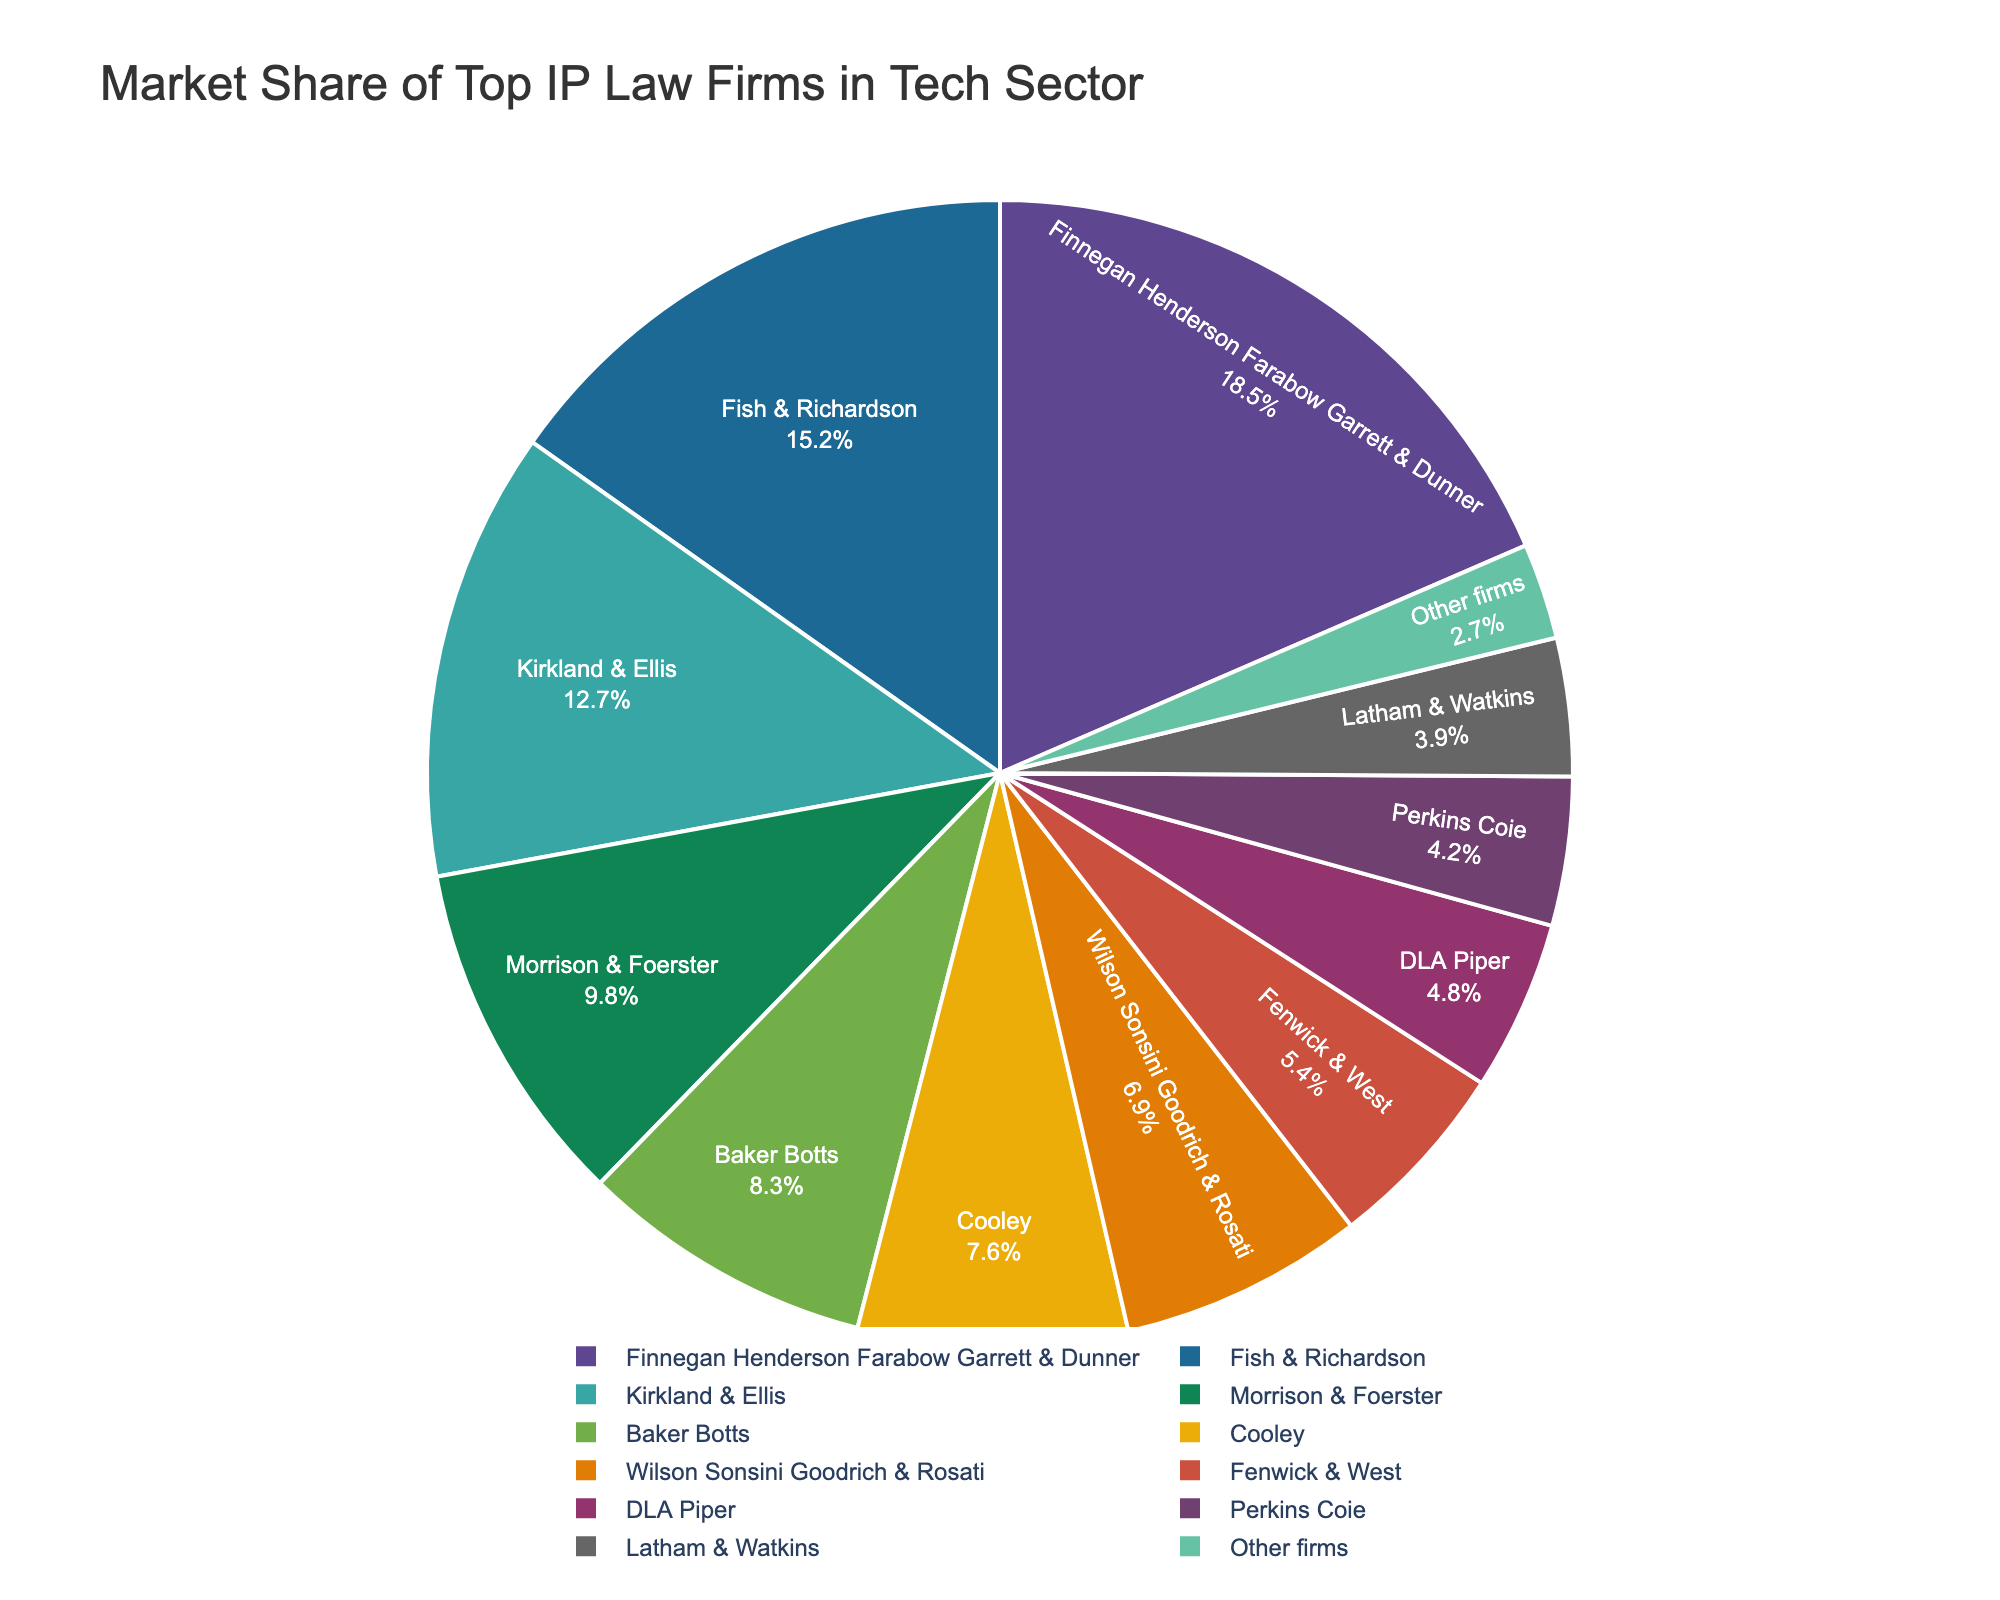What is the market share of the firm with the highest market share? Look for the firm with the largest wedge in the pie chart. The wedge representing Finnegan Henderson Farabow Garrett & Dunner is the largest with 18.5%.
Answer: 18.5% Which firm has the lowest market share, and what is it? Identify the smallest wedge and its corresponding firm. The smallest wedge represents "Other firms" with a market share of 2.7%.
Answer: Other firms, 2.7% How much more market share does Finnegan Henderson Farabow Garrett & Dunner have compared to Fish & Richardson? Subtract the market share of Fish & Richardson (15.2%) from that of Finnegan Henderson Farabow Garrett & Dunner (18.5%). 18.5% - 15.2% = 3.3%.
Answer: 3.3% What is the combined market share of the firms Baker Botts and Cooley? Add the market shares of Baker Botts (8.3%) and Cooley (7.6%). 8.3% + 7.6% = 15.9%.
Answer: 15.9% Which firm appears third in terms of market share? Identify the third-largest wedge in the pie chart. Kirkland & Ellis is third with 12.7%.
Answer: Kirkland & Ellis How does the market share of Morrison & Foerster compare to that of Wilson Sonsini Goodrich & Rosati? Compare the market shares of Morrison & Foerster (9.8%) and Wilson Sonsini Goodrich & Rosati (6.9%). Morrison & Foerster has a higher market share.
Answer: Morrison & Foerster has a higher market share What is the market share range of the top five firms? Identify the market share of the firm with the highest share (Finnegan Henderson Farabow Garrett & Dunner with 18.5%) and the fifth highest share (Baker Botts with 8.3%). The range is 18.5% - 8.3% = 10.2%.
Answer: 10.2% What percentage of the market is held by firms other than the top ten listed firms? Identify the market share labeled "Other firms" which is outside the top ten firms. The market share for "Other firms" is 2.7%.
Answer: 2.7% If you combine the market shares of Fenwick & West and DLA Piper, do they collectively have more market share than Kirkland & Ellis? Add the market shares of Fenwick & West (5.4%) and DLA Piper (4.8%) and compare it to that of Kirkland & Ellis (12.7%). 5.4% + 4.8% = 10.2%, which is less than 12.7%.
Answer: No, they do not Which firms combined make up over 50% of the market? Sequentially add the market shares starting from the highest until the sum exceeds 50%. Finnegan Henderson Farabow Garrett & Dunner (18.5%) + Fish & Richardson (15.2%) + Kirkland & Ellis (12.7%) + Morrison & Foerster (9.8%) = 56.2%.
Answer: Finnegan Henderson Farabow Garrett & Dunner, Fish & Richardson, Kirkland & Ellis, Morrison & Foerster 